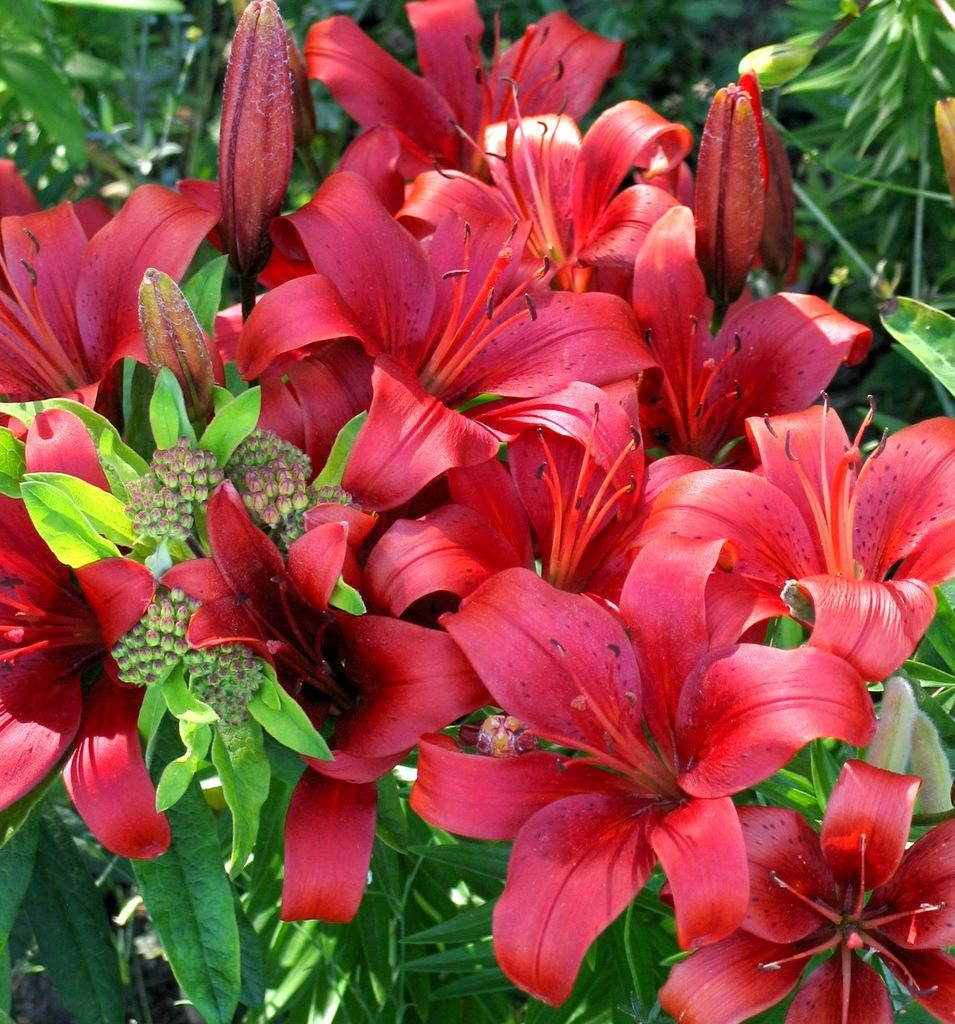What type of flowers are in the middle of the image? There are hibiscus flowers in the middle of the image. What else can be seen in the background of the image? There are plants in the background of the image. What type of machine can be seen in the image? There is no machine present in the image; it features hibiscus flowers and plants. What kind of animal is interacting with the hibiscus flowers in the image? There is no animal present in the image; it only features hibiscus flowers and plants. 